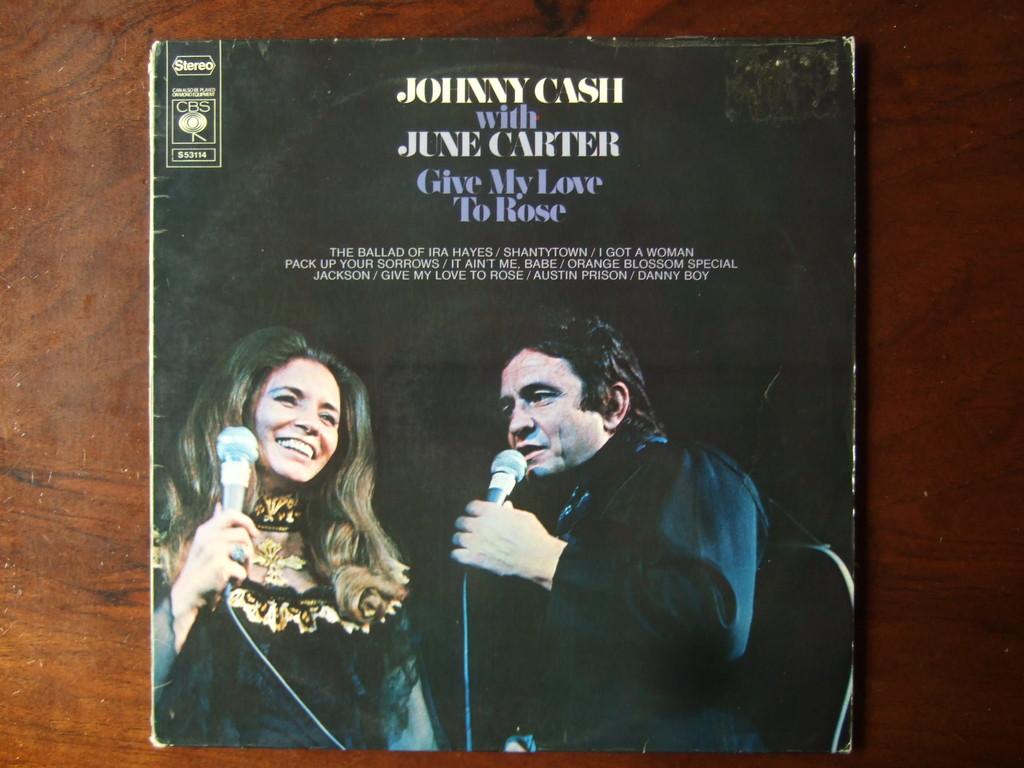What is the title of the album?
Give a very brief answer. Give my love to rose. 